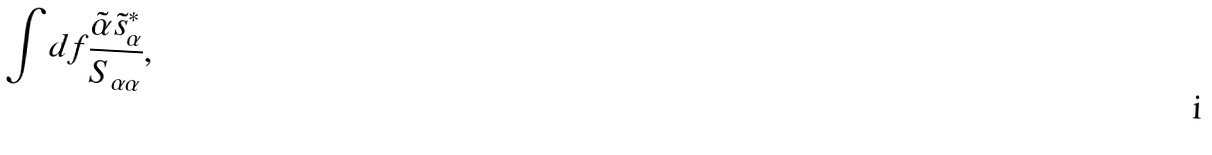<formula> <loc_0><loc_0><loc_500><loc_500>\int d f \frac { \tilde { \alpha } \tilde { s } _ { \alpha } ^ { * } } { S _ { \alpha \alpha } } ,</formula> 